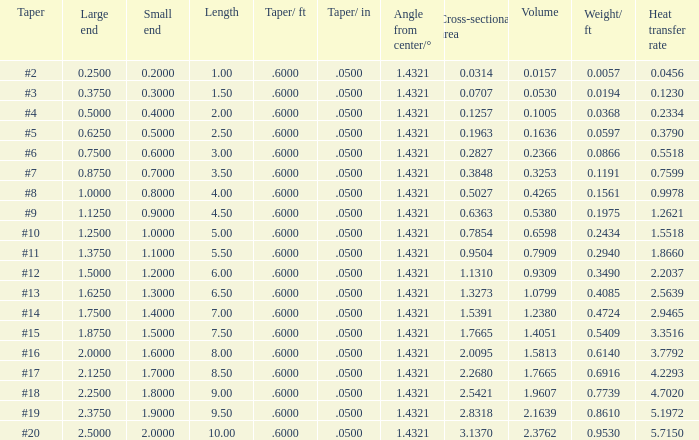Which Taper/in that has a Small end larger than 0.7000000000000001, and a Taper of #19, and a Large end larger than 2.375? None. 